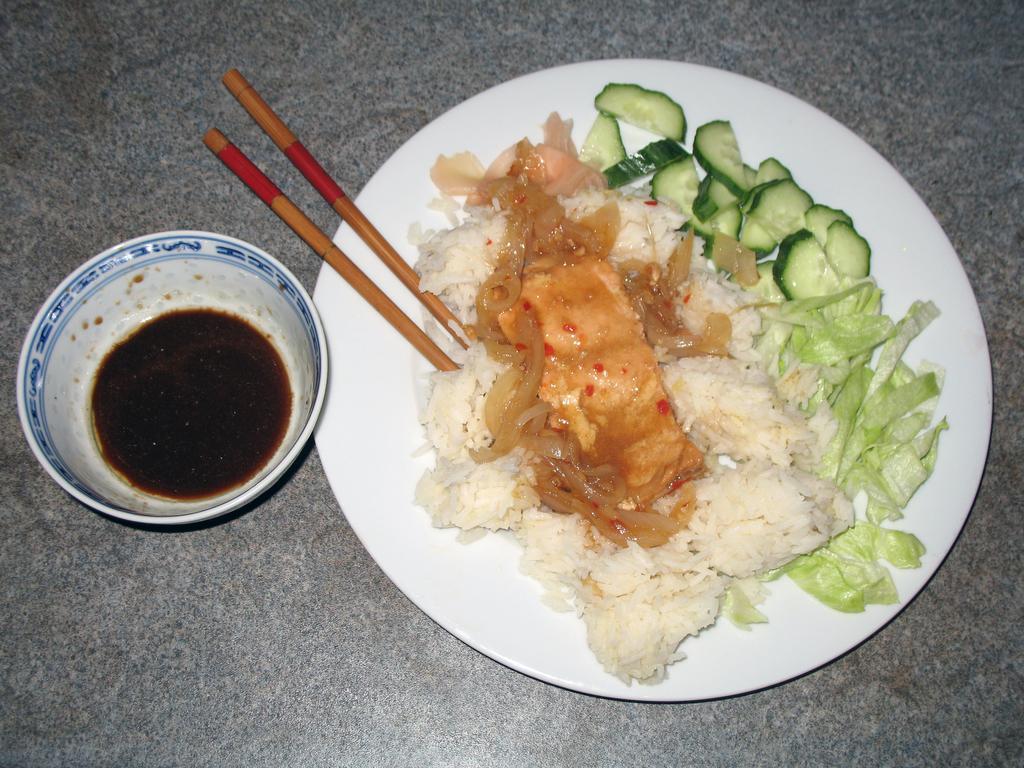Could you give a brief overview of what you see in this image? It is a picture , there is a plate on which some food is arranged there are also two chopsticks beside the plate there is a cup which is filled up of sauce. 